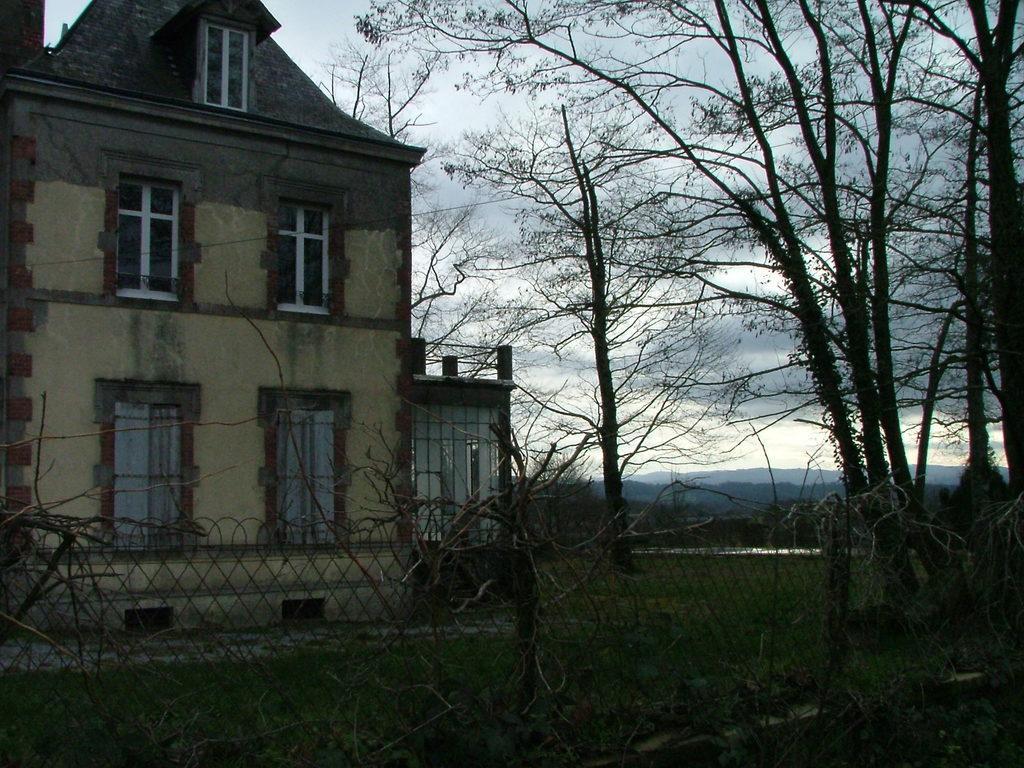Describe this image in one or two sentences. In this image we can see sky with clouds, trees, hills, building, ground, creepers and fence. 